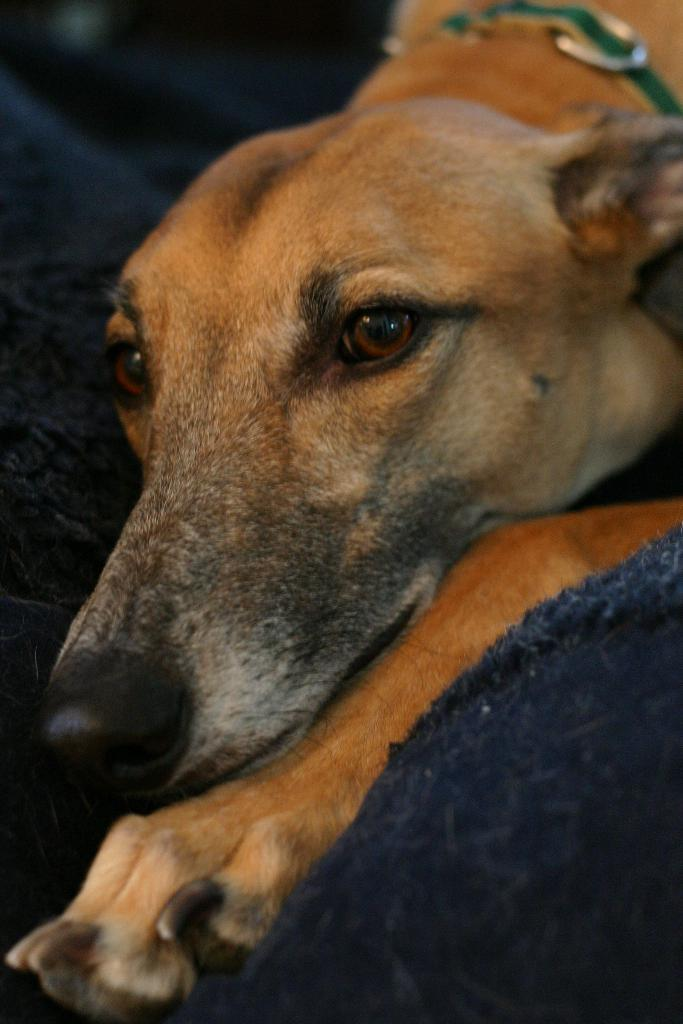What color is the cloth in the image? The cloth in the image is blue. What is on top of the blue cloth? There is a cream-colored dog on the blue cloth. What type of teeth can be seen in the image? There are no teeth visible in the image, as it features a blue cloth with a cream-colored dog on it. How many sticks are being held by the goat in the image? There is no goat present in the image, so it is not possible to determine how many sticks it might be holding. 